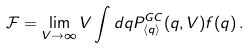Convert formula to latex. <formula><loc_0><loc_0><loc_500><loc_500>\mathcal { F } = \lim _ { V \to \infty } V \int d q { P } _ { \langle q \rangle } ^ { G C } ( q , V ) f ( q ) \, .</formula> 